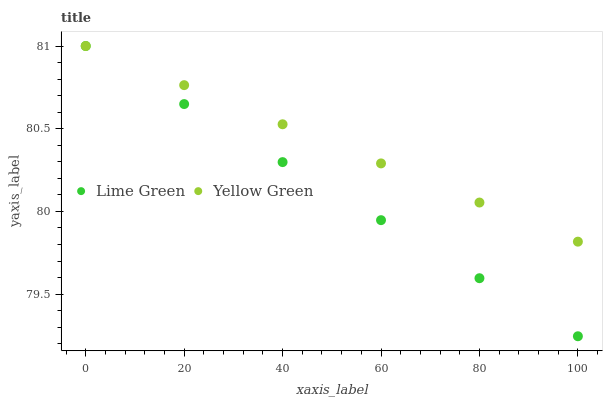Does Lime Green have the minimum area under the curve?
Answer yes or no. Yes. Does Yellow Green have the maximum area under the curve?
Answer yes or no. Yes. Does Yellow Green have the minimum area under the curve?
Answer yes or no. No. Is Yellow Green the smoothest?
Answer yes or no. Yes. Is Lime Green the roughest?
Answer yes or no. Yes. Is Yellow Green the roughest?
Answer yes or no. No. Does Lime Green have the lowest value?
Answer yes or no. Yes. Does Yellow Green have the lowest value?
Answer yes or no. No. Does Yellow Green have the highest value?
Answer yes or no. Yes. Does Lime Green intersect Yellow Green?
Answer yes or no. Yes. Is Lime Green less than Yellow Green?
Answer yes or no. No. Is Lime Green greater than Yellow Green?
Answer yes or no. No. 